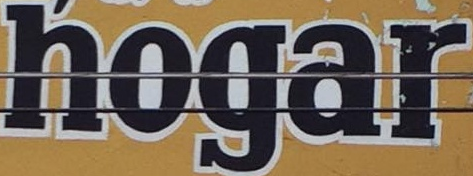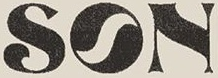Read the text content from these images in order, separated by a semicolon. hogar; SON 